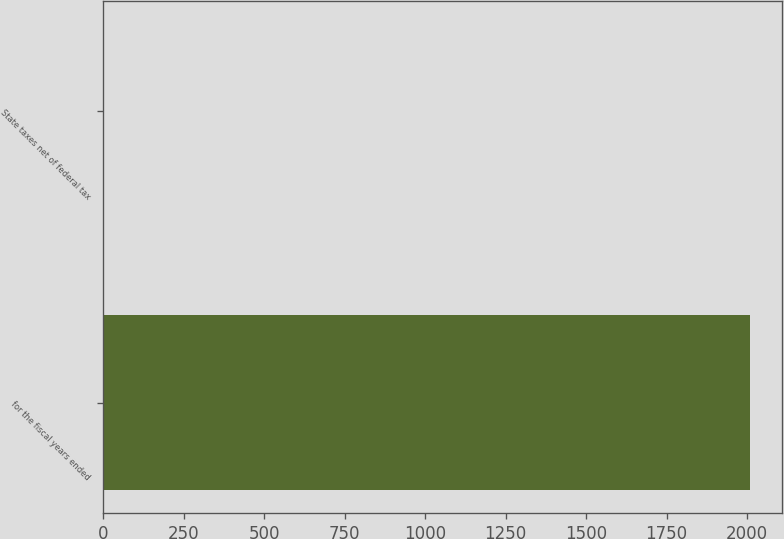Convert chart. <chart><loc_0><loc_0><loc_500><loc_500><bar_chart><fcel>for the fiscal years ended<fcel>State taxes net of federal tax<nl><fcel>2008<fcel>1.83<nl></chart> 